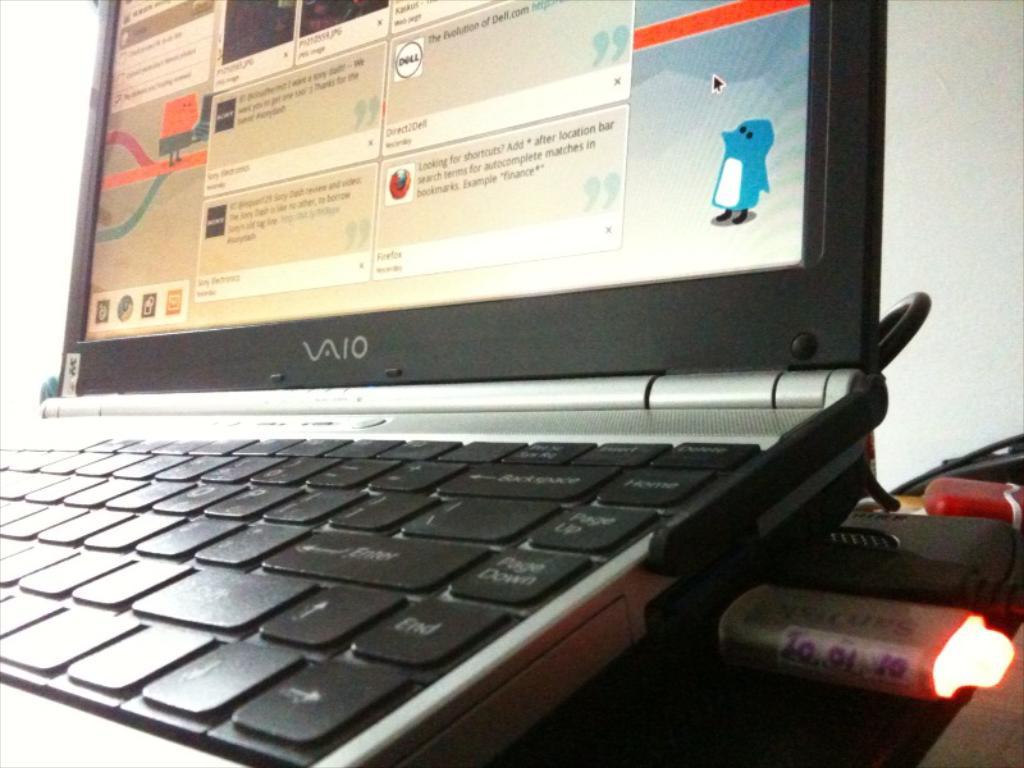What brand of laptop is this?
Offer a terse response. Vaio. What is the first word on the message on the bottom right corner of the screen say?
Offer a terse response. Looking. 